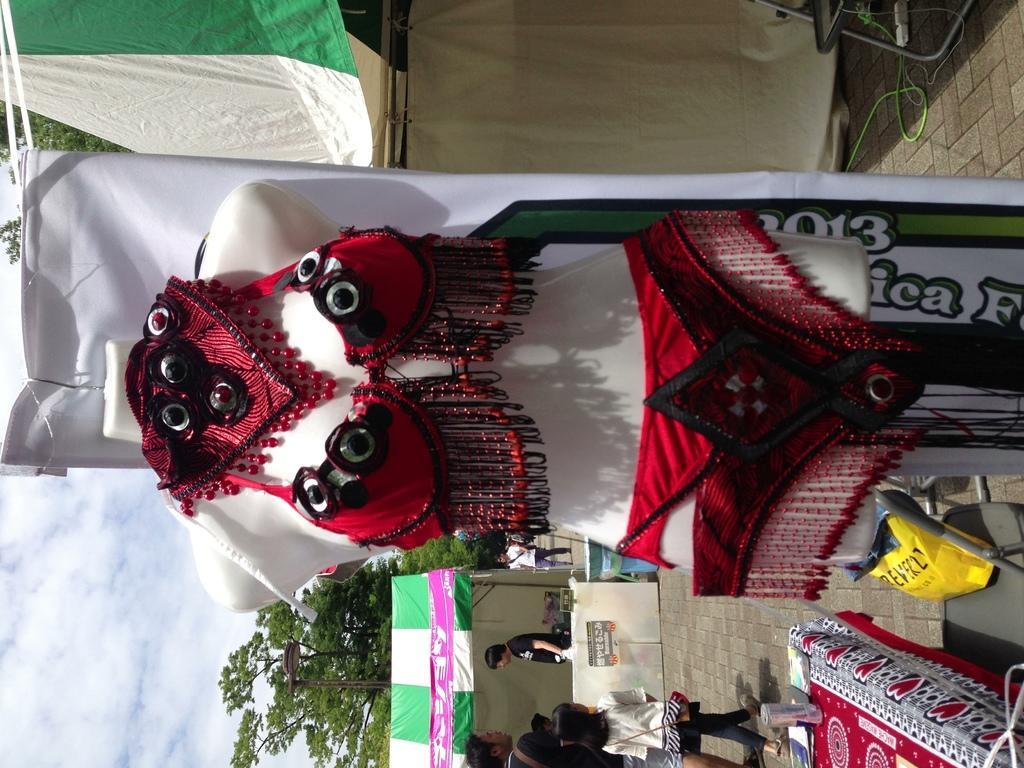How would you summarize this image in a sentence or two? In this image, we can see costumes on a mannequin. At the bottom, we can see few people, tent, walkway and few objects. Top of the image, we can see chairs, ropes and few things. On the left side background, we can see trees and cloudy sky. 